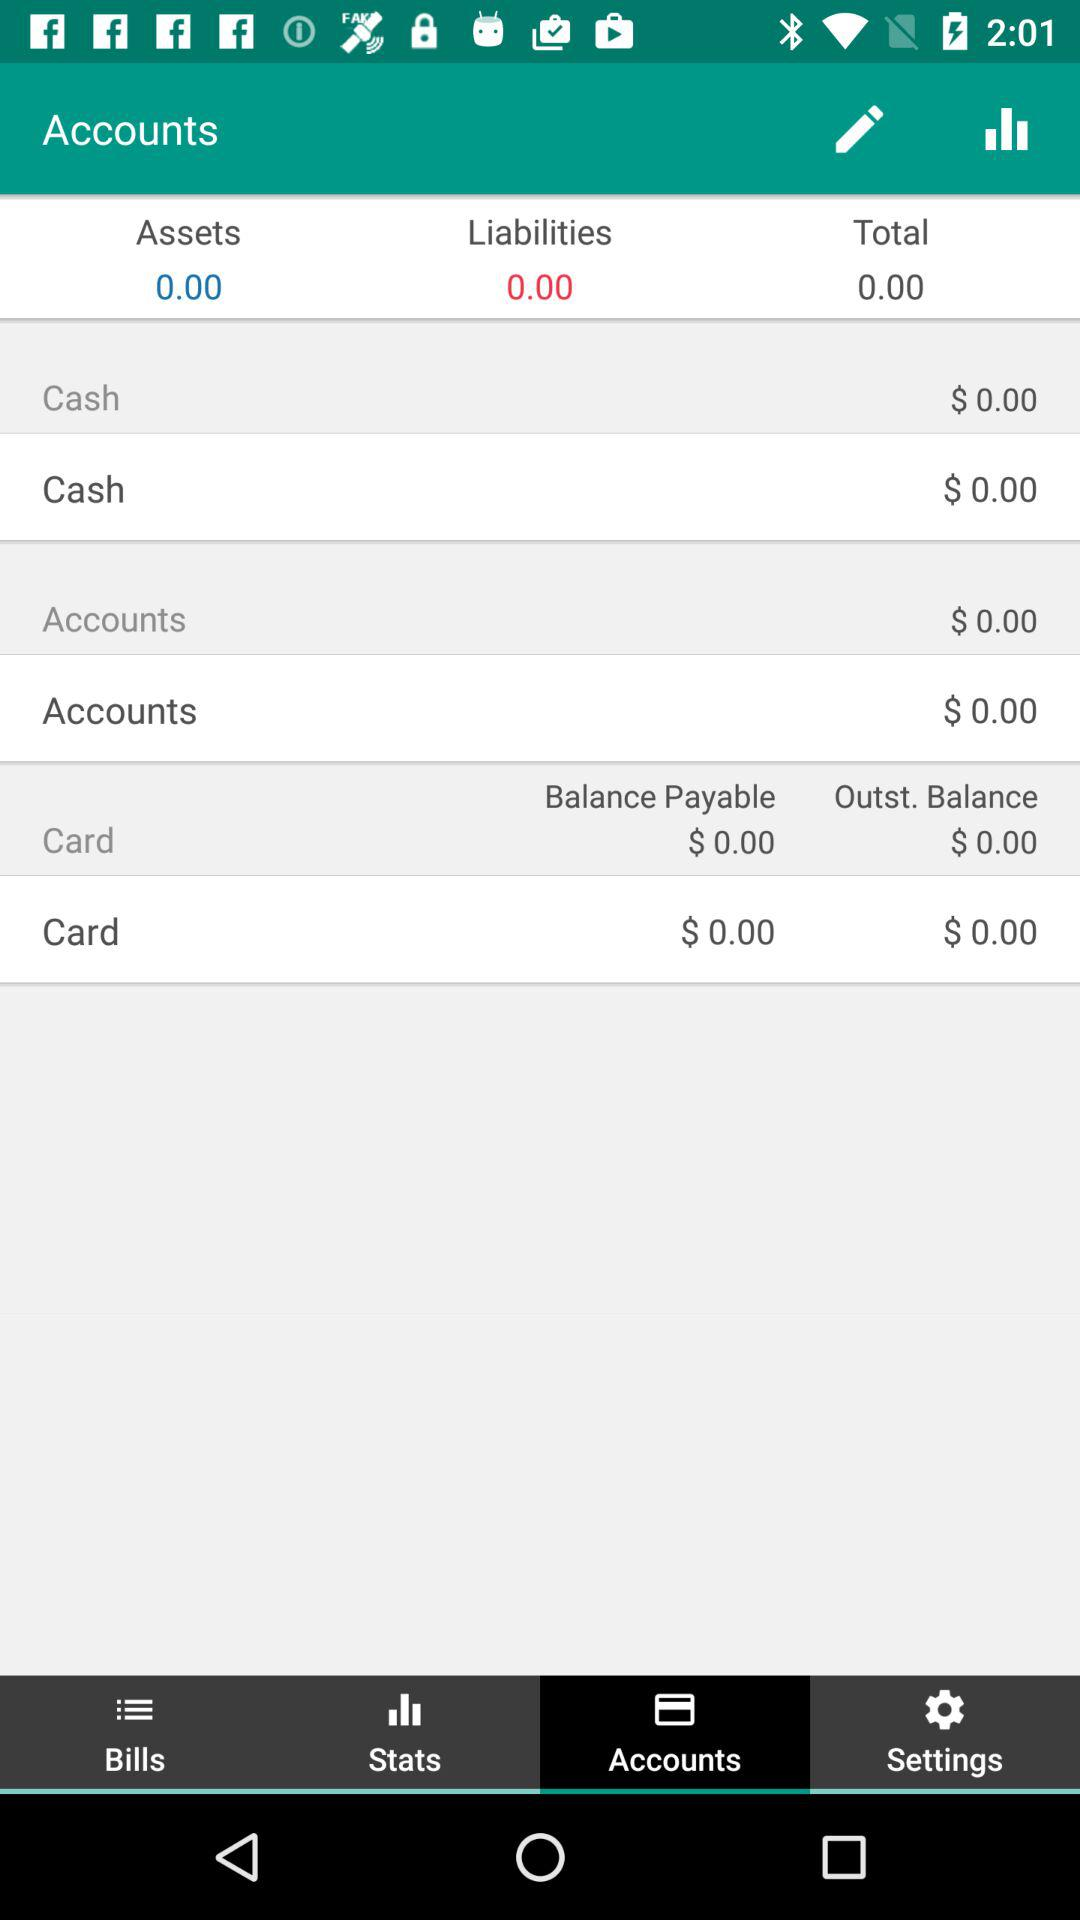What is the outstanding balance? The outstanding balance is $0. 